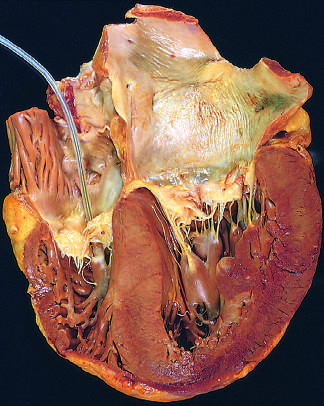re this degree of external dysmorphogenesis left atrium shown on the right in this four-chamber view of the heart?
Answer the question using a single word or phrase. No 